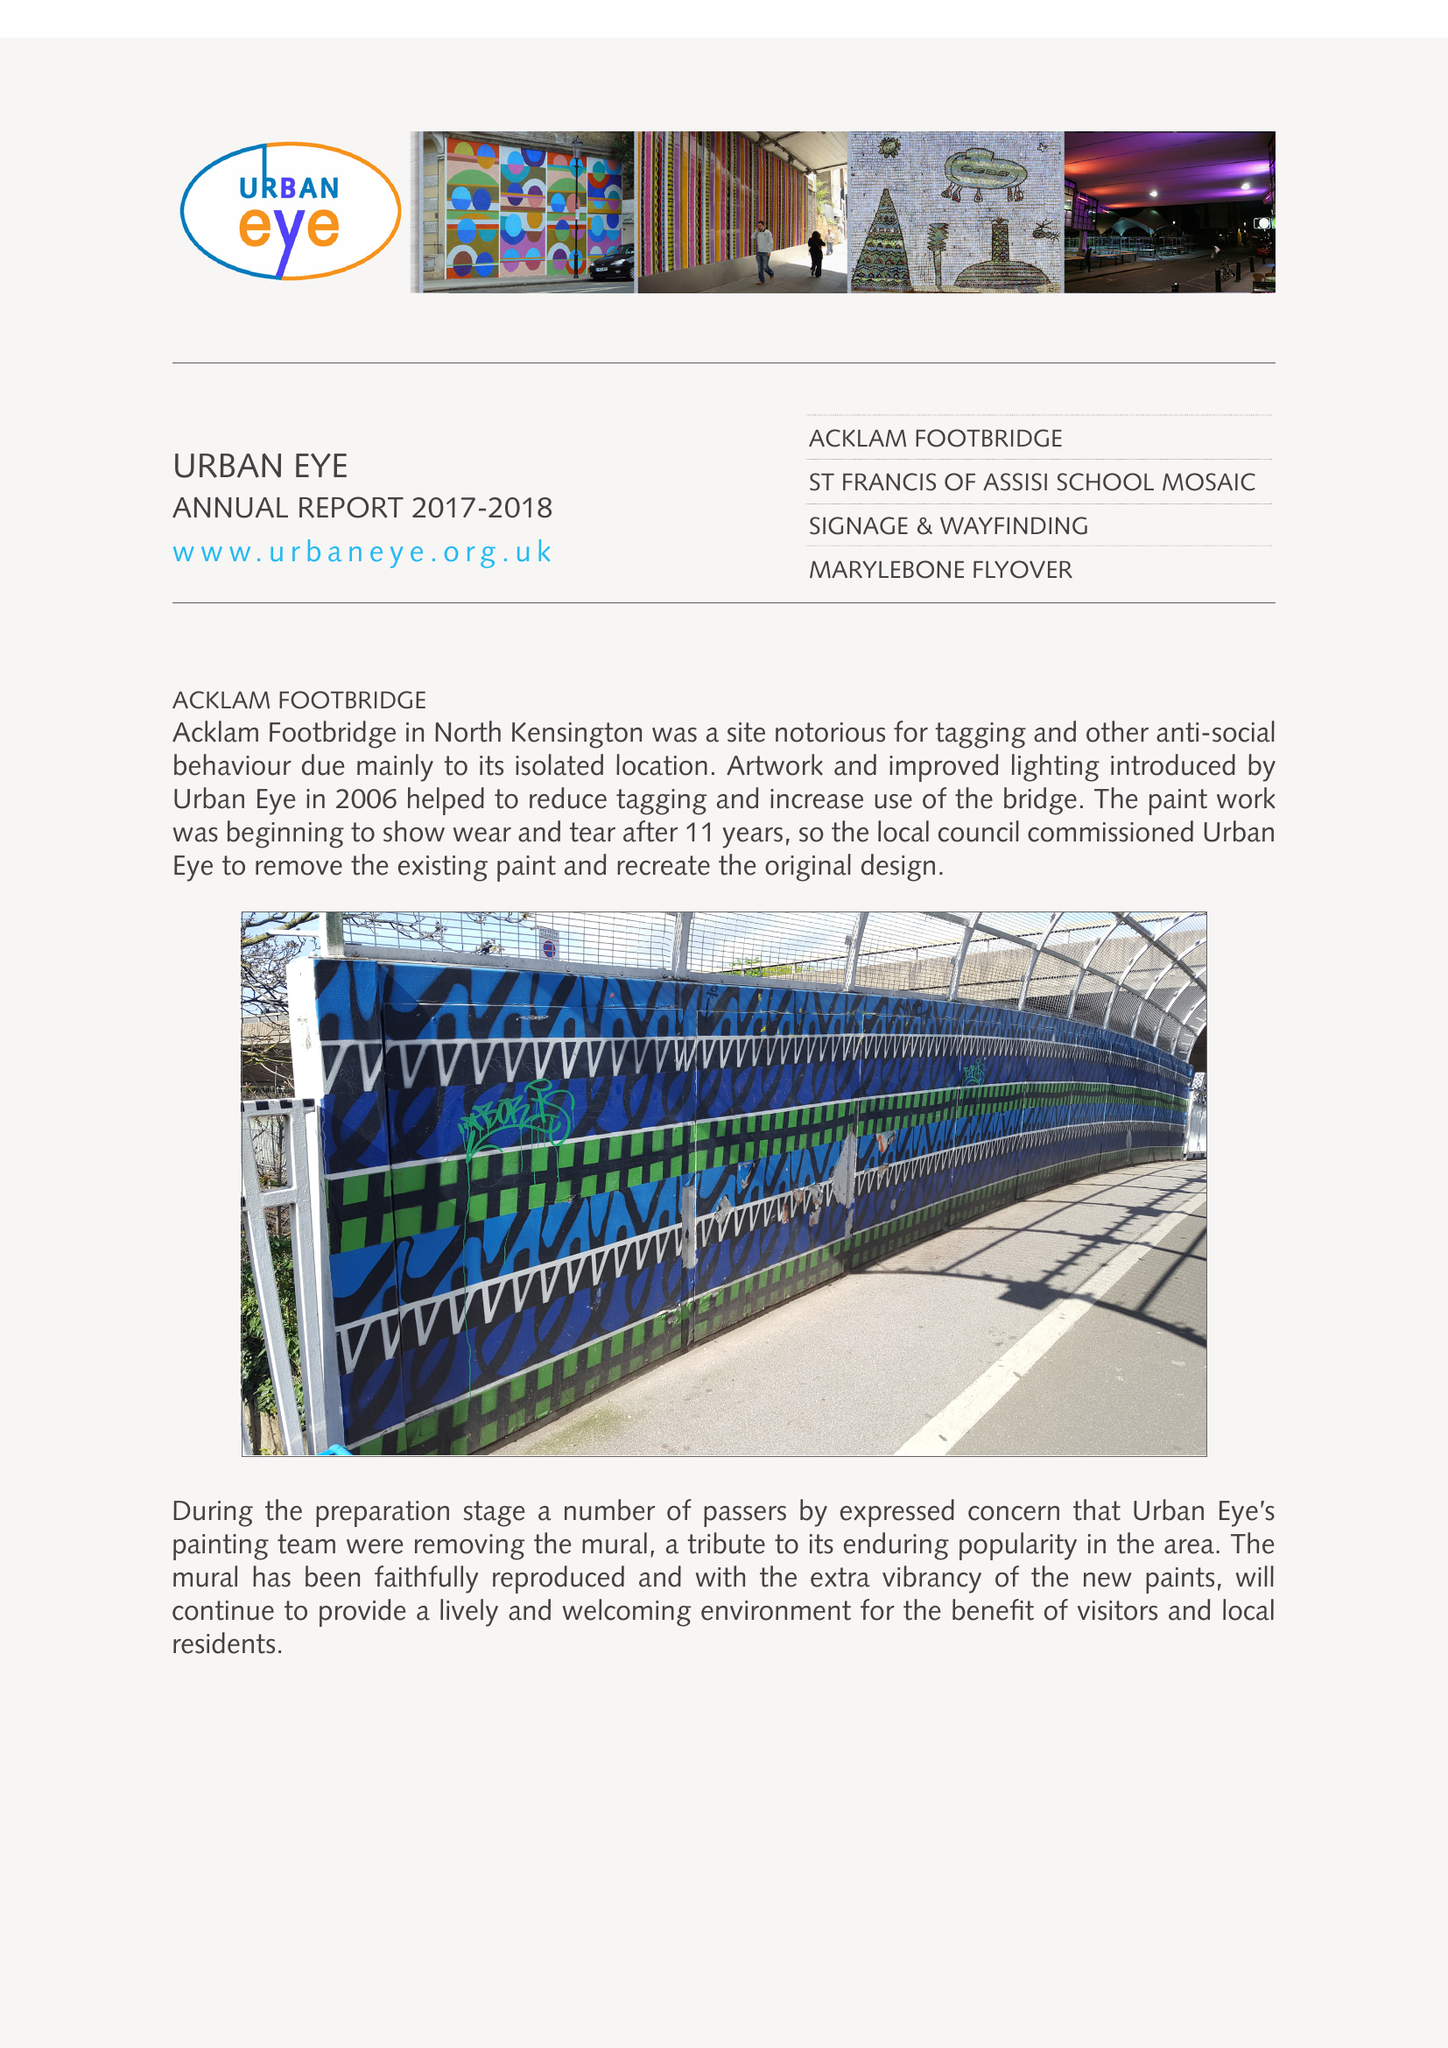What is the value for the address__post_town?
Answer the question using a single word or phrase. LONDON 